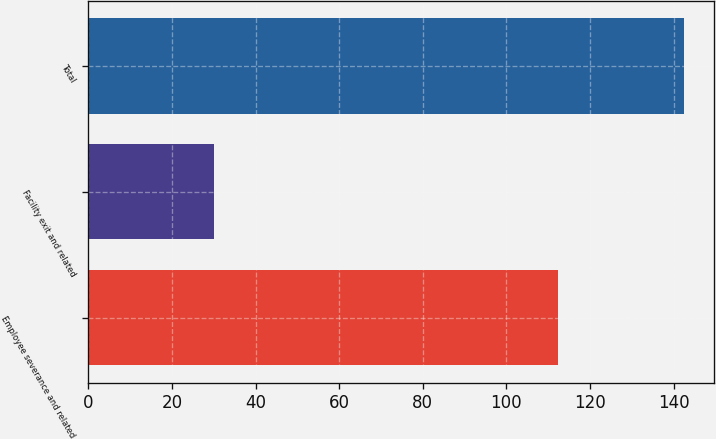Convert chart to OTSL. <chart><loc_0><loc_0><loc_500><loc_500><bar_chart><fcel>Employee severance and related<fcel>Facility exit and related<fcel>Total<nl><fcel>112.4<fcel>30.1<fcel>142.5<nl></chart> 